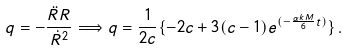Convert formula to latex. <formula><loc_0><loc_0><loc_500><loc_500>q = - \frac { \ddot { R } R } { \dot { R } ^ { 2 } } \Longrightarrow q = \frac { 1 } { 2 c } \{ - 2 c + 3 ( c - 1 ) e ^ { ( - \frac { \alpha k M } { 6 } t ) } \} \, .</formula> 